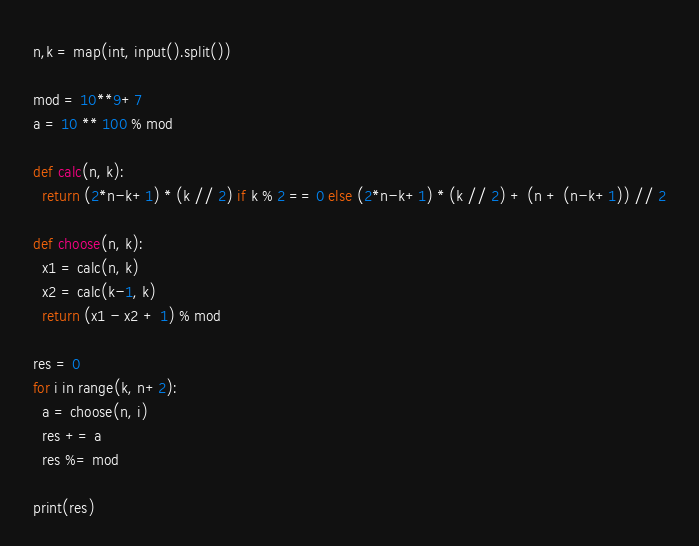Convert code to text. <code><loc_0><loc_0><loc_500><loc_500><_Python_>n,k = map(int, input().split())

mod = 10**9+7
a = 10 ** 100 % mod

def calc(n, k):
  return (2*n-k+1) * (k // 2) if k % 2 == 0 else (2*n-k+1) * (k // 2) + (n + (n-k+1)) // 2

def choose(n, k):
  x1 = calc(n, k)
  x2 = calc(k-1, k)
  return (x1 - x2 + 1) % mod

res = 0
for i in range(k, n+2):
  a = choose(n, i)
  res += a
  res %= mod

print(res)
</code> 